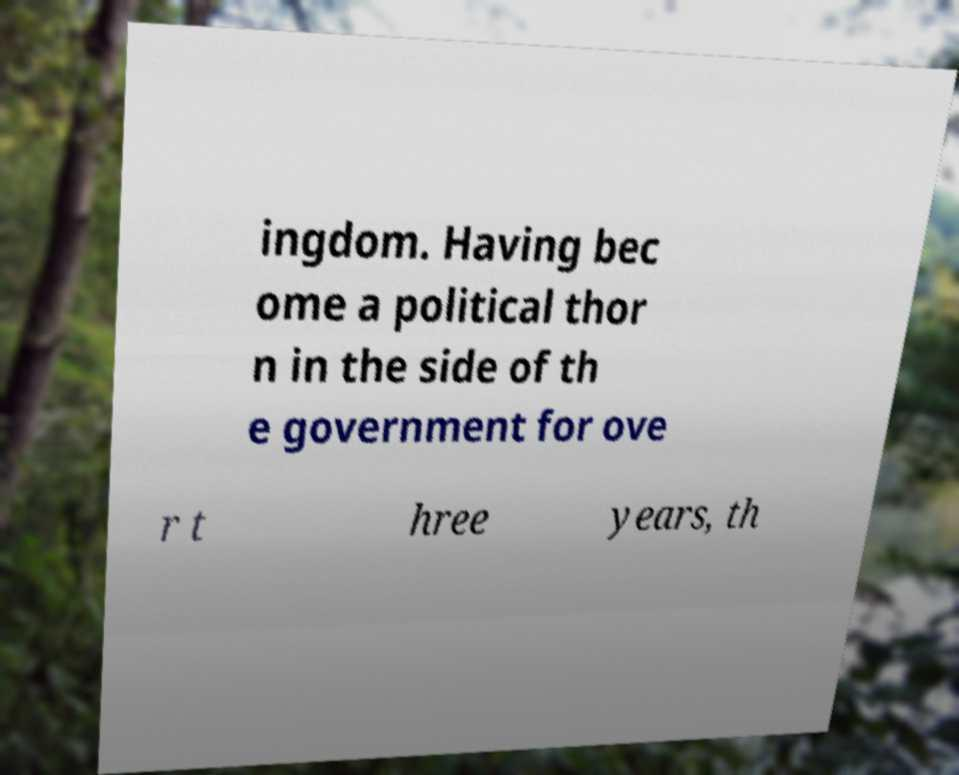What messages or text are displayed in this image? I need them in a readable, typed format. ingdom. Having bec ome a political thor n in the side of th e government for ove r t hree years, th 